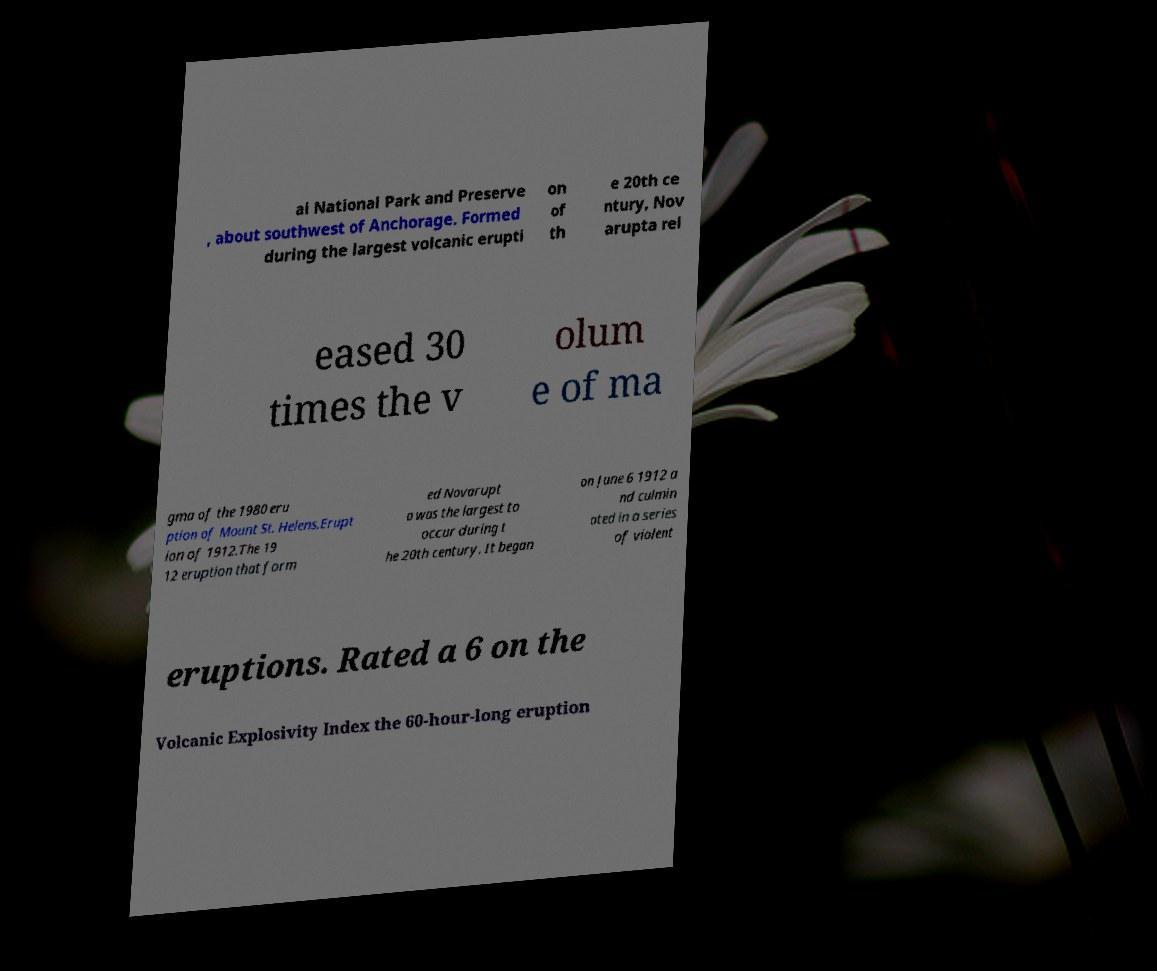Could you assist in decoding the text presented in this image and type it out clearly? ai National Park and Preserve , about southwest of Anchorage. Formed during the largest volcanic erupti on of th e 20th ce ntury, Nov arupta rel eased 30 times the v olum e of ma gma of the 1980 eru ption of Mount St. Helens.Erupt ion of 1912.The 19 12 eruption that form ed Novarupt a was the largest to occur during t he 20th century. It began on June 6 1912 a nd culmin ated in a series of violent eruptions. Rated a 6 on the Volcanic Explosivity Index the 60-hour-long eruption 